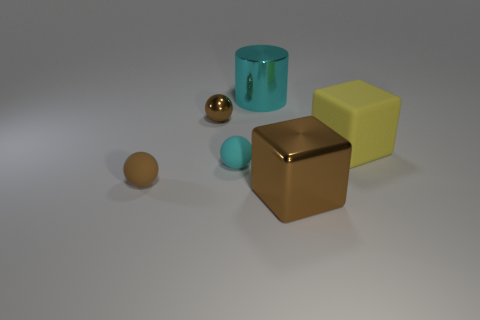Is there anything else that has the same shape as the cyan metallic object?
Provide a short and direct response. No. There is a big cube that is the same color as the tiny shiny thing; what material is it?
Provide a short and direct response. Metal. Do the brown matte object and the cyan matte object in front of the metal sphere have the same shape?
Give a very brief answer. Yes. There is a big object that is the same material as the big cyan cylinder; what is its shape?
Provide a short and direct response. Cube. Are there more small rubber objects that are in front of the metallic ball than small brown metallic spheres in front of the big yellow object?
Your response must be concise. Yes. How many things are either large cyan shiny cylinders or tiny cyan spheres?
Ensure brevity in your answer.  2. What number of other objects are there of the same color as the big rubber object?
Keep it short and to the point. 0. What shape is the brown thing that is the same size as the yellow matte object?
Your answer should be very brief. Cube. What color is the small rubber ball that is to the right of the tiny brown rubber sphere?
Give a very brief answer. Cyan. What number of things are either metallic objects in front of the metallic cylinder or brown things that are in front of the yellow object?
Give a very brief answer. 3. 